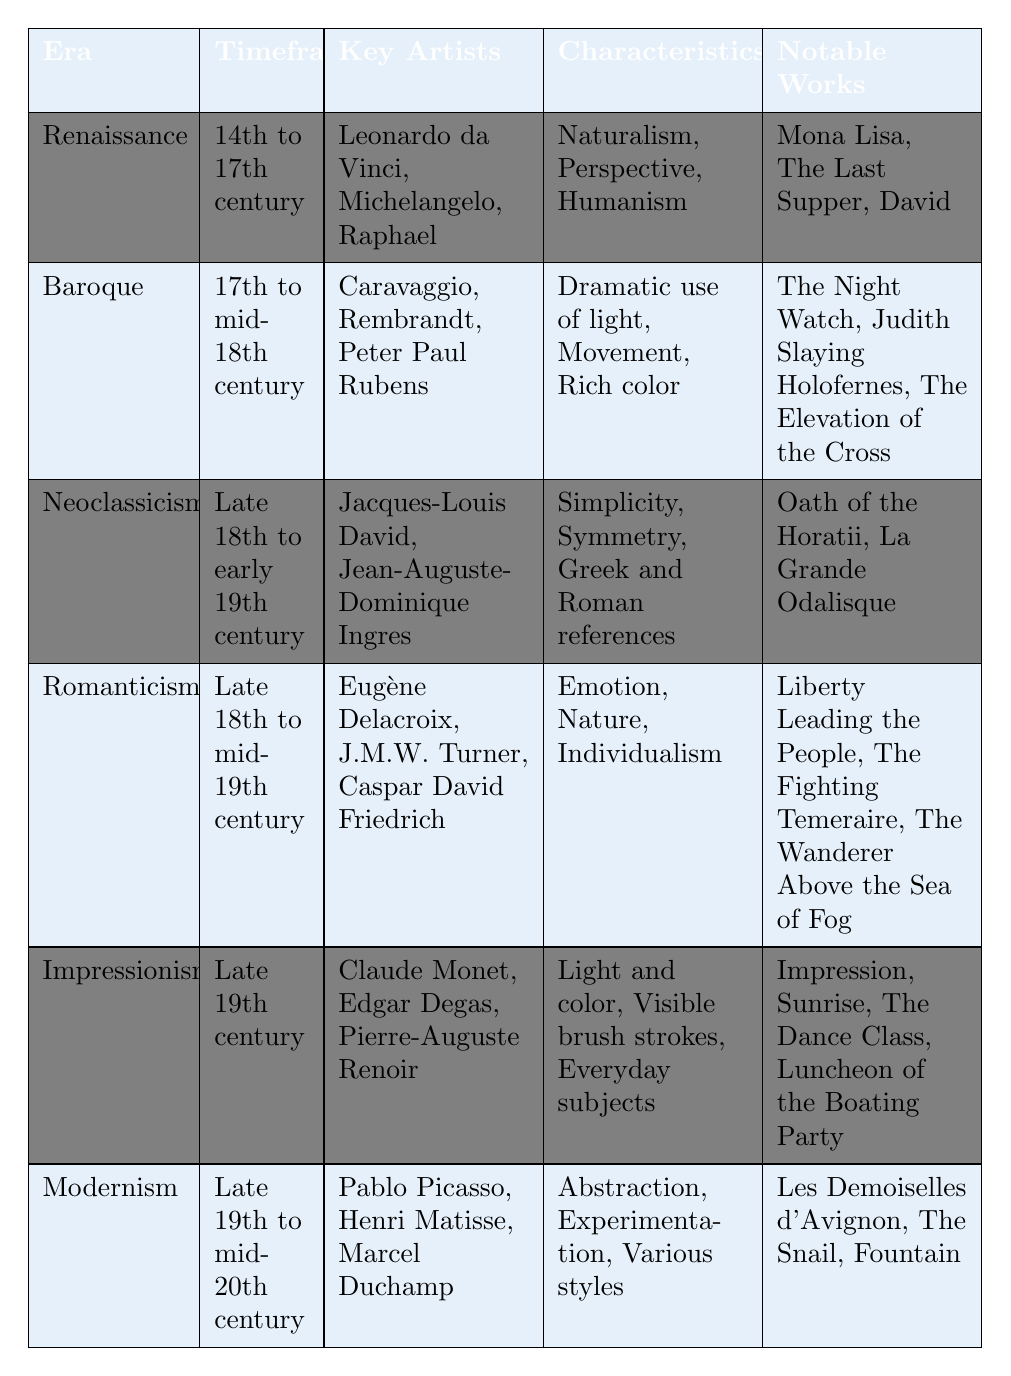What era is associated with the key artist Michelangelo? According to the table, Michelangelo is listed under the Renaissance era.
Answer: Renaissance Which notable work is from the Baroque period? The table lists "The Night Watch," "Judith Slaying Holofernes," and "The Elevation of the Cross" as notable works of the Baroque era.
Answer: The Night Watch How many key artists are associated with Modernism? The table indicates that there are three key artists listed under Modernism: Pablo Picasso, Henri Matisse, and Marcel Duchamp. Therefore, the number is three.
Answer: 3 True or False: Neoclassicism emphasizes emotion and nature. The table specifies that Neoclassicism focuses on simplicity, symmetry, and Greek and Roman references, rather than emotion and nature. Therefore, this statement is false.
Answer: False Which art style has the characteristic of "Visible brush strokes"? In the table, "Visible brush strokes" is identified as a characteristic of Impressionism.
Answer: Impressionism What is the time frame for Romanticism, and how does it compare to Neoclassicism? The time frame for Romanticism is late 18th to mid-19th century, whereas Neoclassicism spans late 18th to early 19th century. Comparing both, Romanticism extends beyond the time frame of Neoclassicism.
Answer: Romanticism extends beyond Neoclassicism Calculate the number of notable works associated with Impressionism. The table lists three notable works for Impressionism: "Impression, Sunrise," "The Dance Class," and "Luncheon of the Boating Party." Therefore, the count is three.
Answer: 3 Which era features the characteristic of dramatic use of light? The table shows that the Baroque era features the characteristic of dramatic use of light.
Answer: Baroque How does the number of key artists in the Renaissance compare to that in Modernism? The Renaissance has three key artists (Leonardo da Vinci, Michelangelo, Raphael), while Modernism also has three key artists (Pablo Picasso, Henri Matisse, Marcel Duchamp). Thus, the counts are equal.
Answer: They are equal 